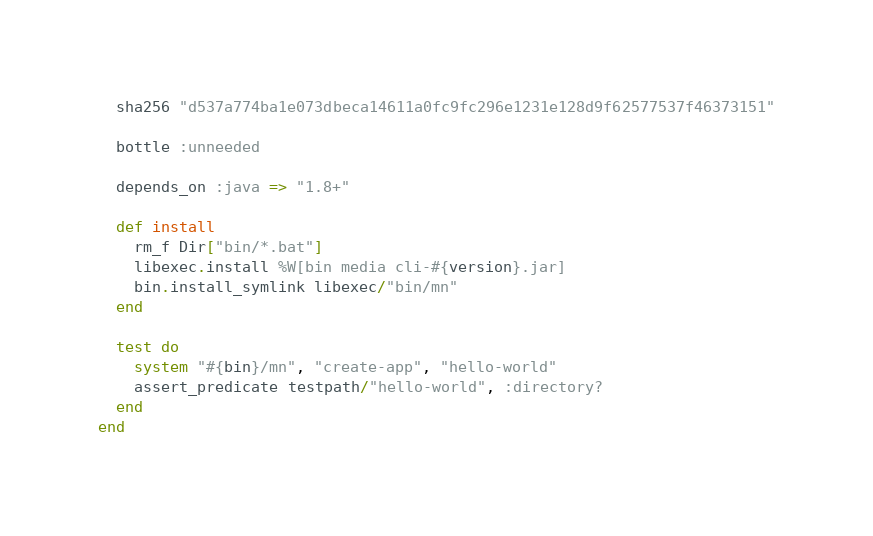<code> <loc_0><loc_0><loc_500><loc_500><_Ruby_>  sha256 "d537a774ba1e073dbeca14611a0fc9fc296e1231e128d9f62577537f46373151"

  bottle :unneeded

  depends_on :java => "1.8+"

  def install
    rm_f Dir["bin/*.bat"]
    libexec.install %W[bin media cli-#{version}.jar]
    bin.install_symlink libexec/"bin/mn"
  end

  test do
    system "#{bin}/mn", "create-app", "hello-world"
    assert_predicate testpath/"hello-world", :directory?
  end
end
</code> 